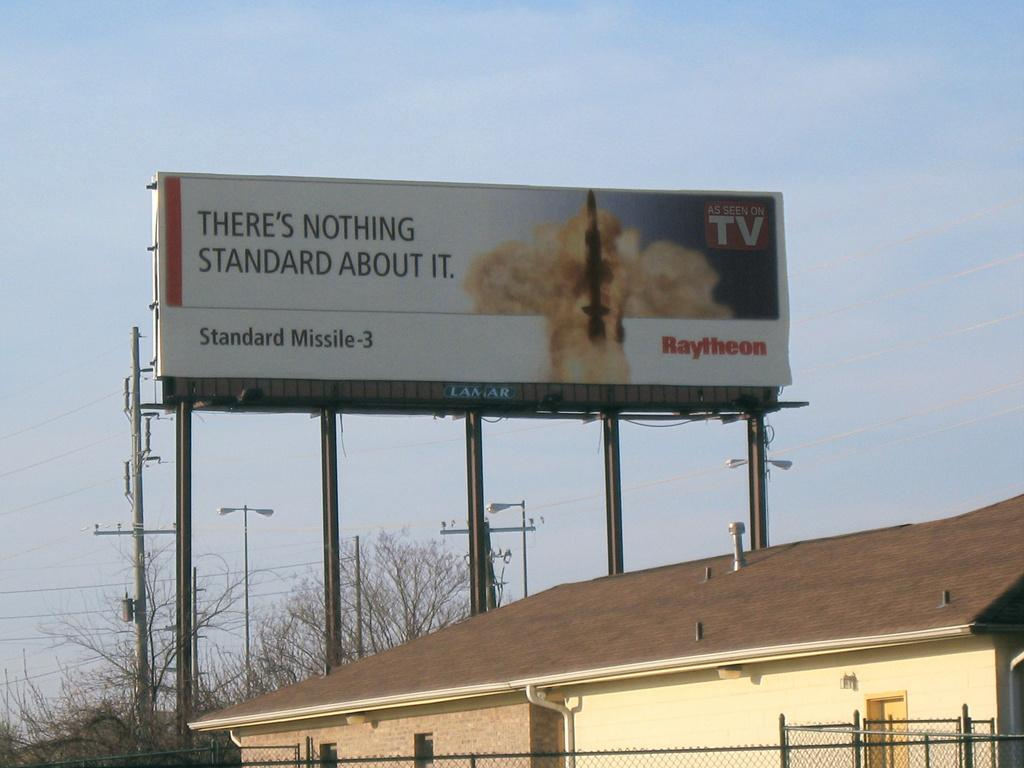<image>
Share a concise interpretation of the image provided. A billboard advertising a missile hanging over someone houses 